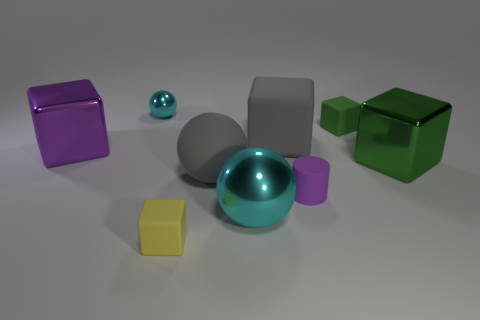Can you tell which object stands out the most and why? The turquoise sphere stands out the most due to its highly reflective surface, which catches the light and creates a noticeable highlight compared to the other objects. Its color is also quite vibrant and distinct from the other objects in the scene. 